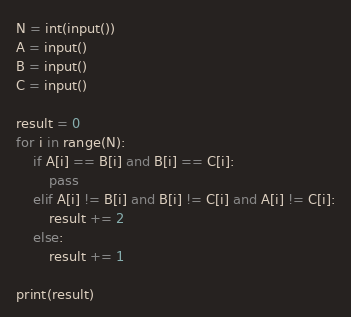Convert code to text. <code><loc_0><loc_0><loc_500><loc_500><_Python_>N = int(input())
A = input()
B = input()
C = input()

result = 0
for i in range(N):
    if A[i] == B[i] and B[i] == C[i]:
        pass
    elif A[i] != B[i] and B[i] != C[i] and A[i] != C[i]:
        result += 2
    else:
        result += 1

print(result)
</code> 